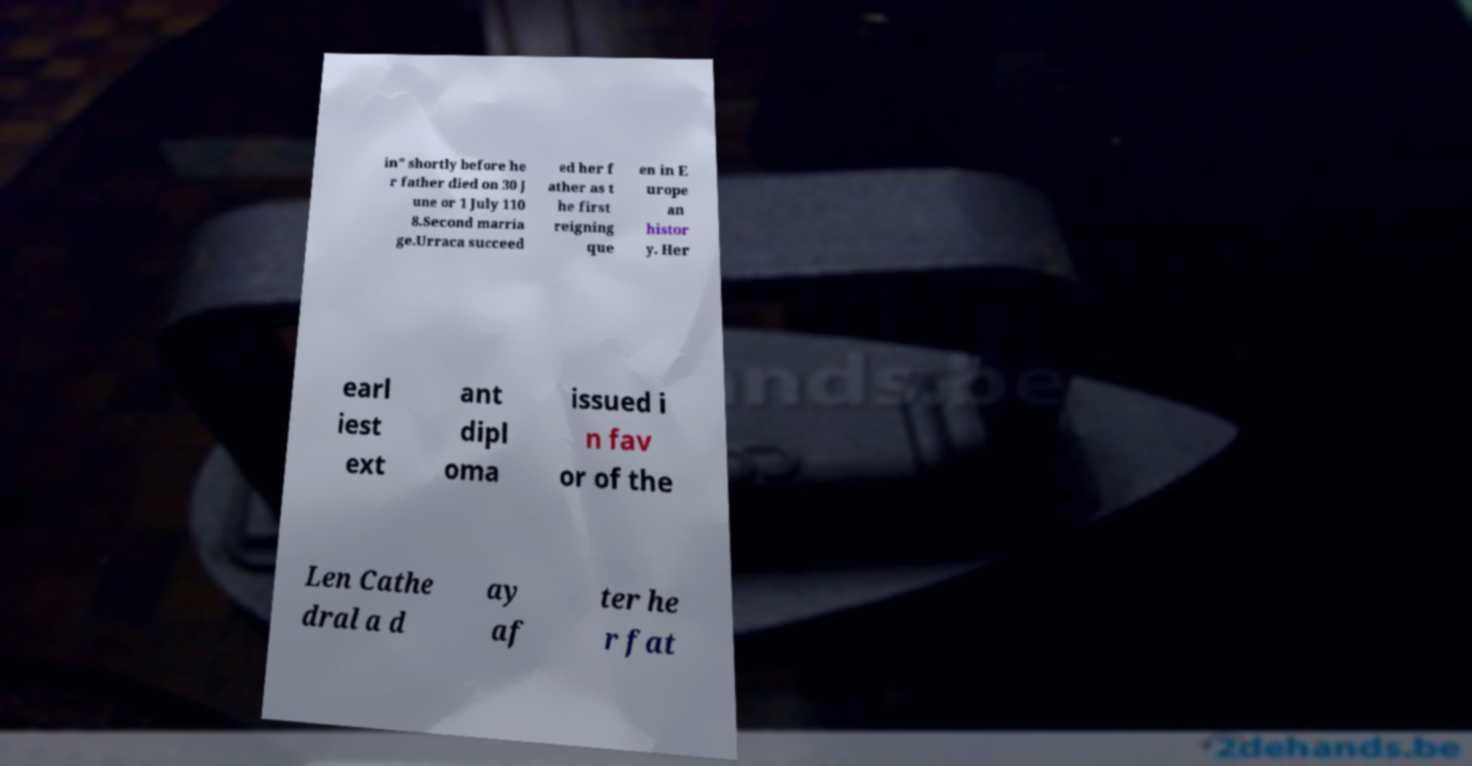Can you read and provide the text displayed in the image?This photo seems to have some interesting text. Can you extract and type it out for me? in" shortly before he r father died on 30 J une or 1 July 110 8.Second marria ge.Urraca succeed ed her f ather as t he first reigning que en in E urope an histor y. Her earl iest ext ant dipl oma issued i n fav or of the Len Cathe dral a d ay af ter he r fat 